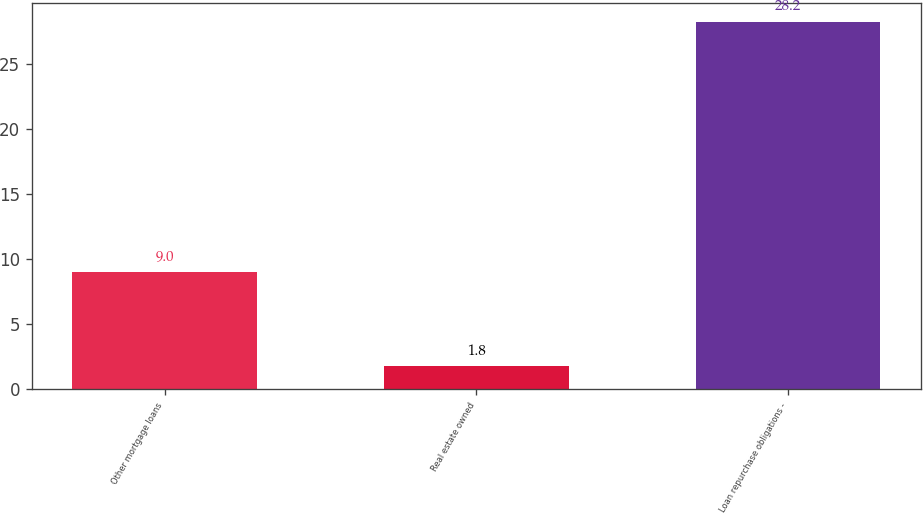<chart> <loc_0><loc_0><loc_500><loc_500><bar_chart><fcel>Other mortgage loans<fcel>Real estate owned<fcel>Loan repurchase obligations -<nl><fcel>9<fcel>1.8<fcel>28.2<nl></chart> 